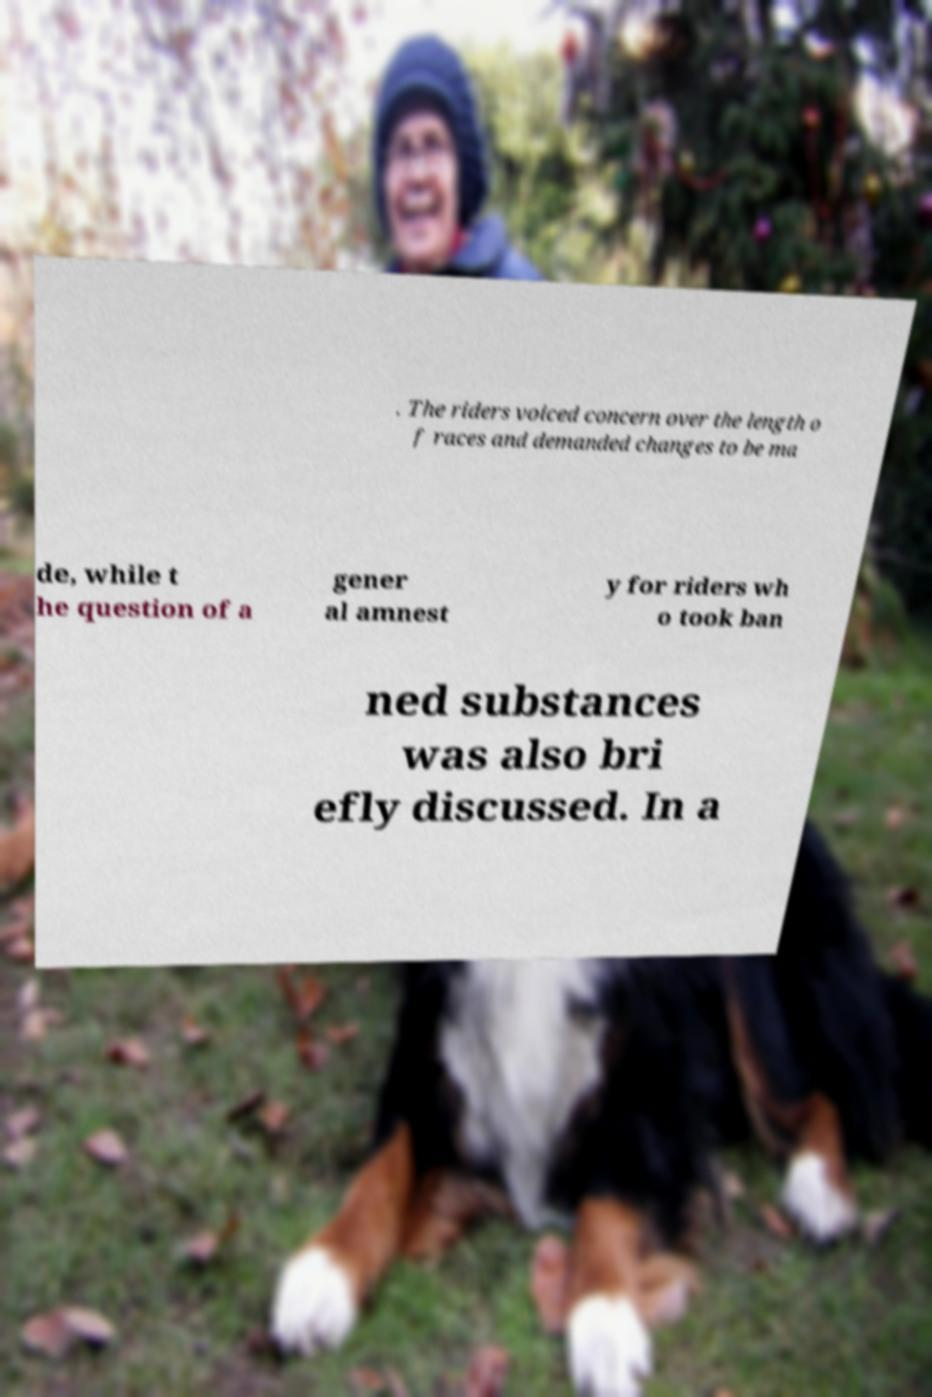For documentation purposes, I need the text within this image transcribed. Could you provide that? . The riders voiced concern over the length o f races and demanded changes to be ma de, while t he question of a gener al amnest y for riders wh o took ban ned substances was also bri efly discussed. In a 